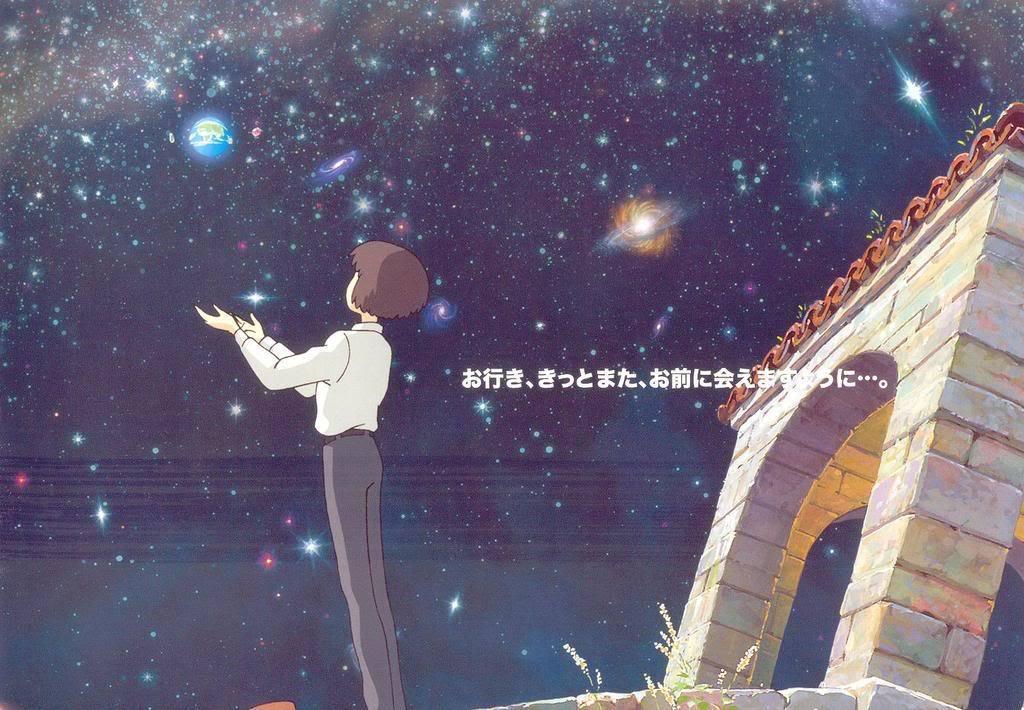Can you describe this image briefly? In the picture we can see a cartoon image of a boy standing and showing his hands to the sky, the sky is with full of stars and behind the boy we can see a gateway. 